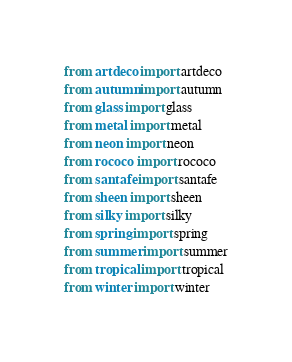Convert code to text. <code><loc_0><loc_0><loc_500><loc_500><_Python_>from artdeco import artdeco
from autumn import autumn
from glass import glass
from metal import metal
from neon import neon
from rococo import rococo
from santafe import santafe
from sheen import sheen
from silky import silky
from spring import spring
from summer import summer
from tropical import tropical
from winter import winter
</code> 